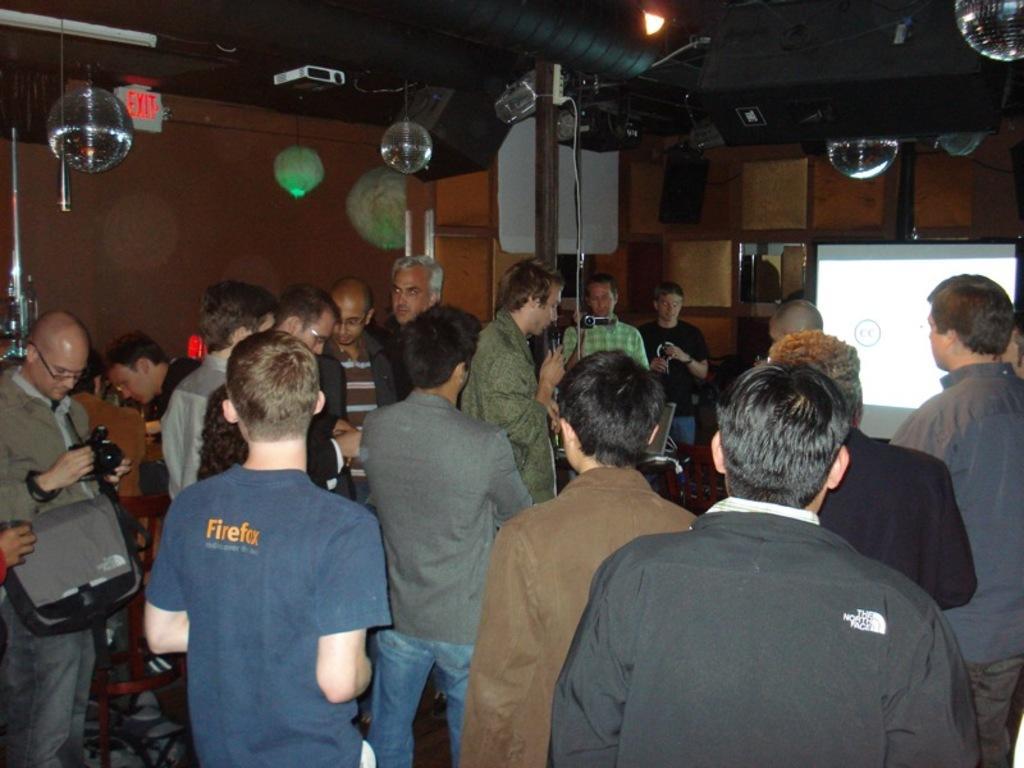Describe this image in one or two sentences. In this image there are people, screen, light, speakers, cameras, exit board, wall and objects. Among them few people are holding objects. 